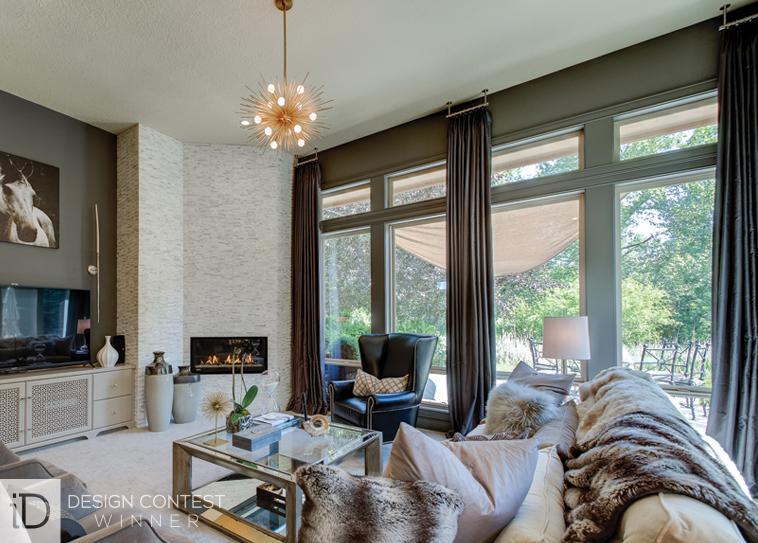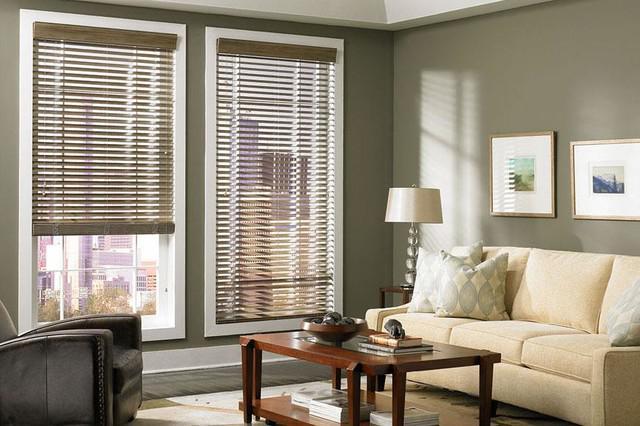The first image is the image on the left, the second image is the image on the right. Analyze the images presented: Is the assertion "There is at least one plant in the right image" valid? Answer yes or no. No. The first image is the image on the left, the second image is the image on the right. Analyze the images presented: Is the assertion "In at least one image there are three blinds with two at the same height." valid? Answer yes or no. No. 